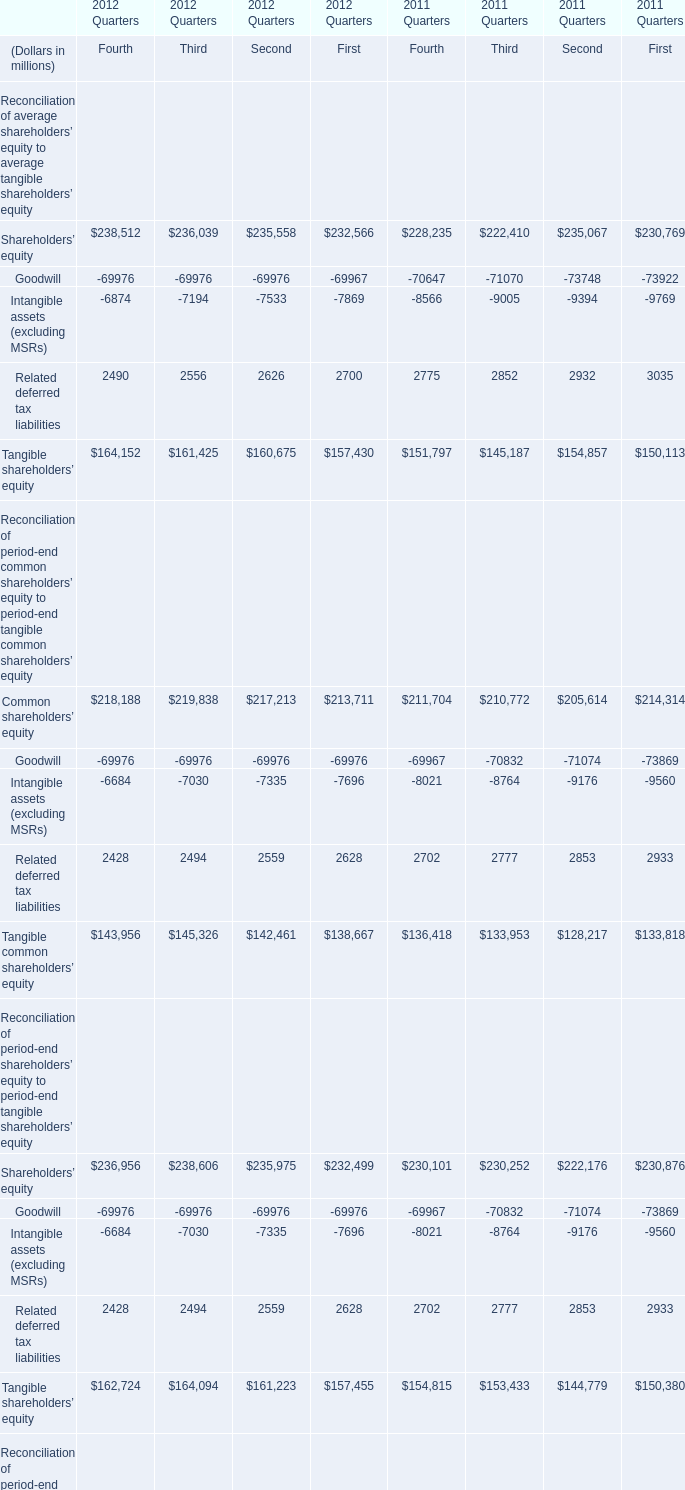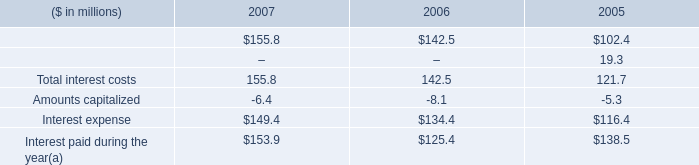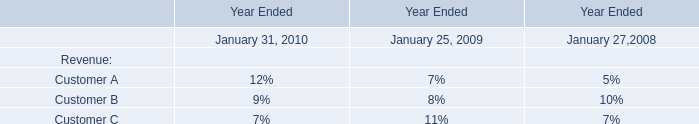Which year is Related deferred tax liabilities the highest for Fourth? 
Answer: 2011 Quarters. 